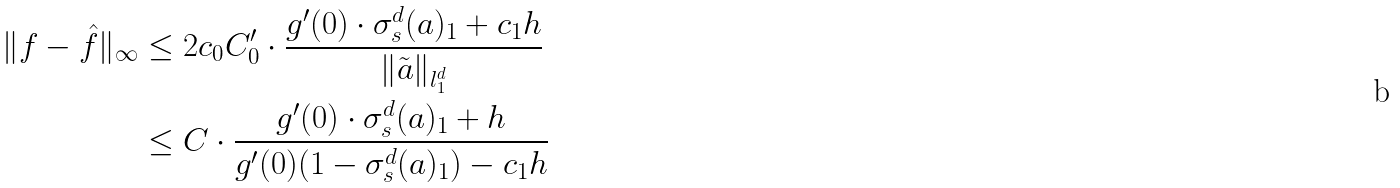<formula> <loc_0><loc_0><loc_500><loc_500>\| f - \hat { f } \| _ { \infty } & \leq 2 c _ { 0 } C _ { 0 } ^ { \prime } \cdot \frac { g ^ { \prime } ( 0 ) \cdot \sigma _ { s } ^ { d } ( a ) _ { 1 } + c _ { 1 } h } { \| \tilde { a } \| _ { l _ { 1 } ^ { d } } } \\ & \leq C \cdot \frac { g ^ { \prime } ( 0 ) \cdot \sigma _ { s } ^ { d } ( a ) _ { 1 } + h } { g ^ { \prime } ( 0 ) ( 1 - \sigma _ { s } ^ { d } ( a ) _ { 1 } ) - c _ { 1 } h }</formula> 